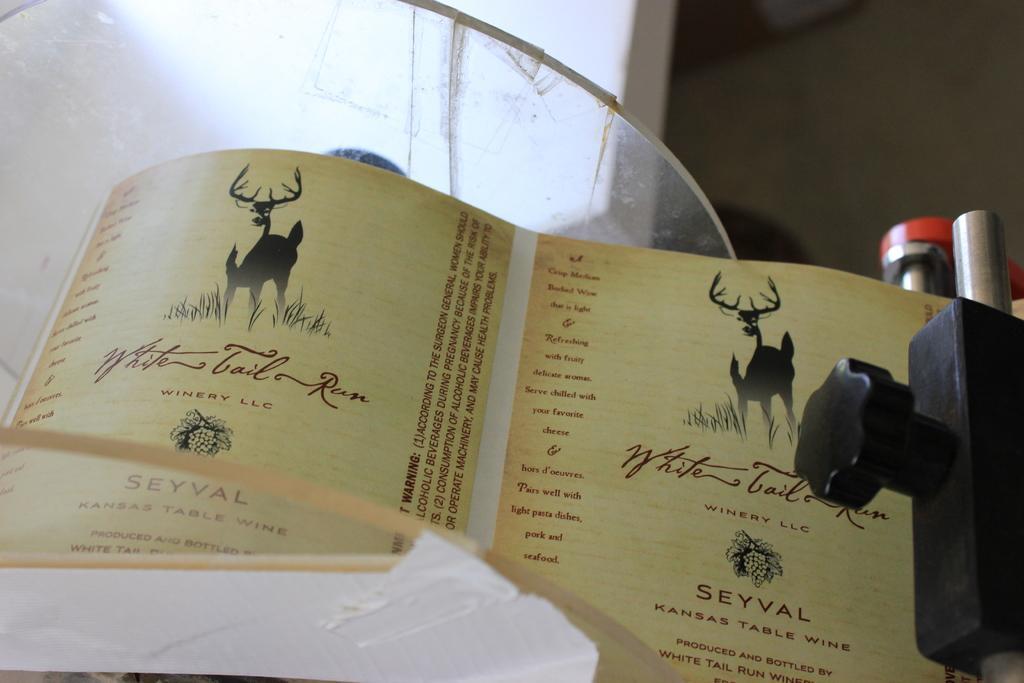Could you give a brief overview of what you see in this image? In this image we can see a paper with some pictures and text placed on the surface. On the right side of the image we can see some devices. 